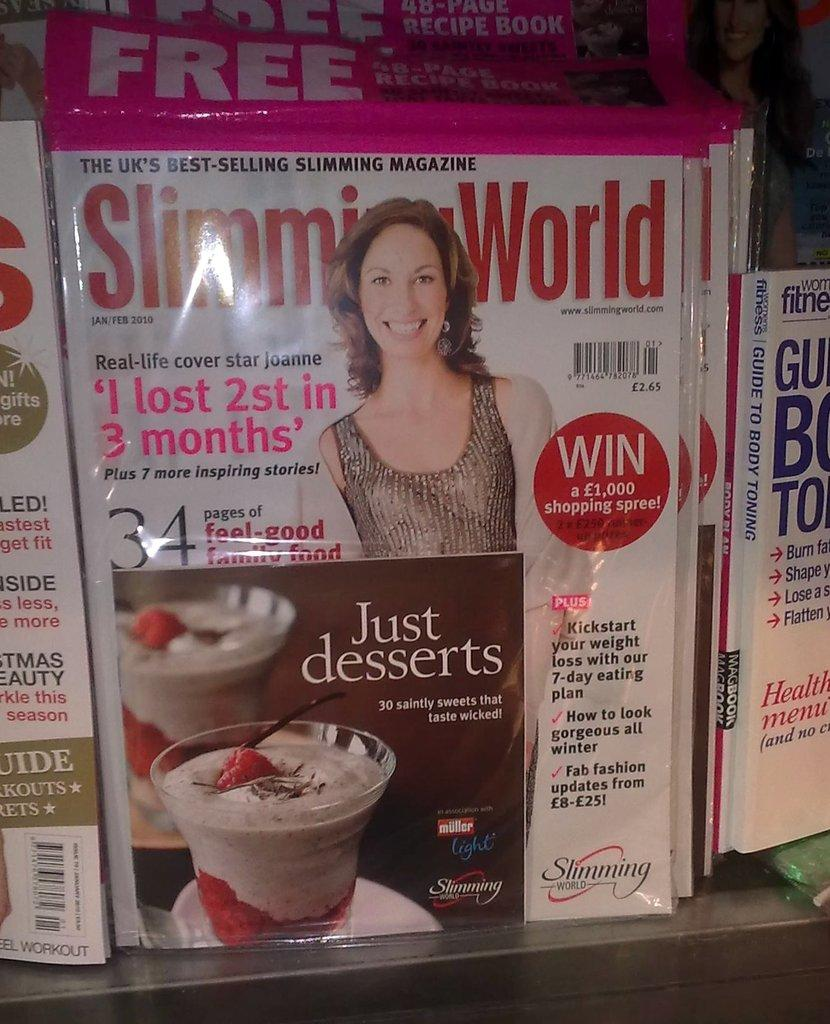<image>
Relay a brief, clear account of the picture shown. A Slimming World magazine is on display with a free 40 page recipe book 